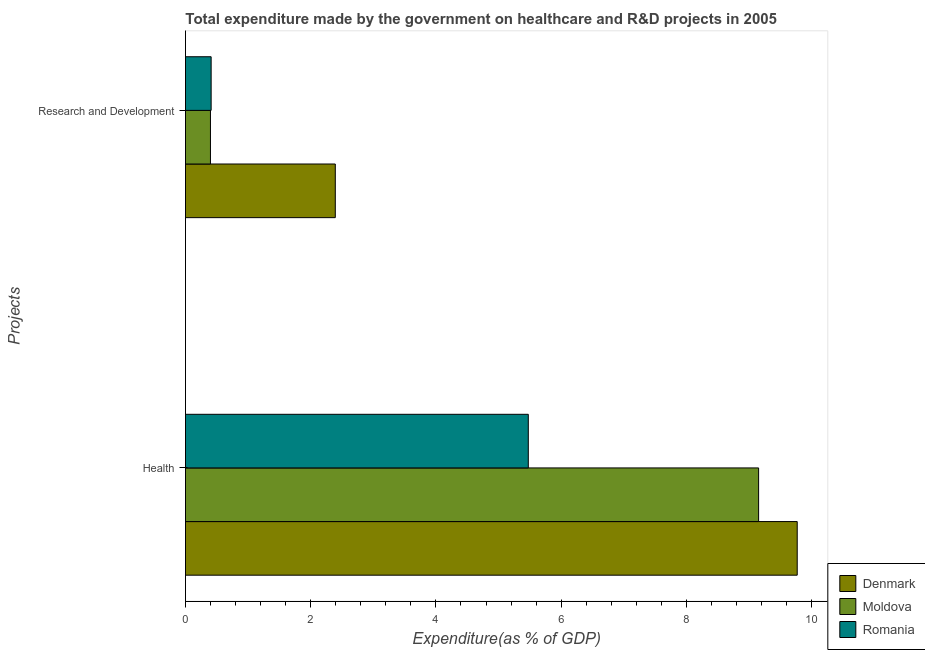How many different coloured bars are there?
Provide a succinct answer. 3. How many bars are there on the 1st tick from the bottom?
Your answer should be compact. 3. What is the label of the 2nd group of bars from the top?
Your answer should be very brief. Health. What is the expenditure in r&d in Romania?
Offer a very short reply. 0.41. Across all countries, what is the maximum expenditure in r&d?
Offer a terse response. 2.39. Across all countries, what is the minimum expenditure in r&d?
Your response must be concise. 0.4. In which country was the expenditure in r&d maximum?
Ensure brevity in your answer.  Denmark. In which country was the expenditure in healthcare minimum?
Ensure brevity in your answer.  Romania. What is the total expenditure in r&d in the graph?
Keep it short and to the point. 3.2. What is the difference between the expenditure in healthcare in Denmark and that in Moldova?
Your response must be concise. 0.62. What is the difference between the expenditure in r&d in Denmark and the expenditure in healthcare in Moldova?
Provide a succinct answer. -6.76. What is the average expenditure in r&d per country?
Provide a succinct answer. 1.07. What is the difference between the expenditure in healthcare and expenditure in r&d in Romania?
Provide a short and direct response. 5.07. What is the ratio of the expenditure in r&d in Denmark to that in Moldova?
Your answer should be very brief. 6. What does the 1st bar from the top in Research and Development represents?
Give a very brief answer. Romania. What does the 2nd bar from the bottom in Health represents?
Offer a terse response. Moldova. How many bars are there?
Offer a terse response. 6. How many countries are there in the graph?
Provide a short and direct response. 3. What is the difference between two consecutive major ticks on the X-axis?
Give a very brief answer. 2. Are the values on the major ticks of X-axis written in scientific E-notation?
Your response must be concise. No. Does the graph contain any zero values?
Keep it short and to the point. No. Where does the legend appear in the graph?
Ensure brevity in your answer.  Bottom right. How many legend labels are there?
Provide a succinct answer. 3. How are the legend labels stacked?
Your answer should be compact. Vertical. What is the title of the graph?
Ensure brevity in your answer.  Total expenditure made by the government on healthcare and R&D projects in 2005. What is the label or title of the X-axis?
Your response must be concise. Expenditure(as % of GDP). What is the label or title of the Y-axis?
Provide a succinct answer. Projects. What is the Expenditure(as % of GDP) of Denmark in Health?
Offer a terse response. 9.77. What is the Expenditure(as % of GDP) of Moldova in Health?
Your answer should be very brief. 9.15. What is the Expenditure(as % of GDP) of Romania in Health?
Your response must be concise. 5.48. What is the Expenditure(as % of GDP) of Denmark in Research and Development?
Make the answer very short. 2.39. What is the Expenditure(as % of GDP) in Moldova in Research and Development?
Make the answer very short. 0.4. What is the Expenditure(as % of GDP) in Romania in Research and Development?
Offer a very short reply. 0.41. Across all Projects, what is the maximum Expenditure(as % of GDP) of Denmark?
Your answer should be very brief. 9.77. Across all Projects, what is the maximum Expenditure(as % of GDP) of Moldova?
Your answer should be very brief. 9.15. Across all Projects, what is the maximum Expenditure(as % of GDP) of Romania?
Your answer should be compact. 5.48. Across all Projects, what is the minimum Expenditure(as % of GDP) in Denmark?
Give a very brief answer. 2.39. Across all Projects, what is the minimum Expenditure(as % of GDP) in Moldova?
Offer a terse response. 0.4. Across all Projects, what is the minimum Expenditure(as % of GDP) in Romania?
Keep it short and to the point. 0.41. What is the total Expenditure(as % of GDP) in Denmark in the graph?
Your answer should be compact. 12.16. What is the total Expenditure(as % of GDP) in Moldova in the graph?
Your answer should be very brief. 9.55. What is the total Expenditure(as % of GDP) of Romania in the graph?
Make the answer very short. 5.88. What is the difference between the Expenditure(as % of GDP) in Denmark in Health and that in Research and Development?
Offer a very short reply. 7.38. What is the difference between the Expenditure(as % of GDP) of Moldova in Health and that in Research and Development?
Offer a very short reply. 8.75. What is the difference between the Expenditure(as % of GDP) in Romania in Health and that in Research and Development?
Provide a short and direct response. 5.07. What is the difference between the Expenditure(as % of GDP) of Denmark in Health and the Expenditure(as % of GDP) of Moldova in Research and Development?
Ensure brevity in your answer.  9.37. What is the difference between the Expenditure(as % of GDP) of Denmark in Health and the Expenditure(as % of GDP) of Romania in Research and Development?
Offer a terse response. 9.36. What is the difference between the Expenditure(as % of GDP) in Moldova in Health and the Expenditure(as % of GDP) in Romania in Research and Development?
Your answer should be very brief. 8.74. What is the average Expenditure(as % of GDP) of Denmark per Projects?
Your answer should be compact. 6.08. What is the average Expenditure(as % of GDP) in Moldova per Projects?
Offer a very short reply. 4.78. What is the average Expenditure(as % of GDP) of Romania per Projects?
Keep it short and to the point. 2.94. What is the difference between the Expenditure(as % of GDP) in Denmark and Expenditure(as % of GDP) in Moldova in Health?
Your answer should be compact. 0.62. What is the difference between the Expenditure(as % of GDP) in Denmark and Expenditure(as % of GDP) in Romania in Health?
Your answer should be compact. 4.29. What is the difference between the Expenditure(as % of GDP) of Moldova and Expenditure(as % of GDP) of Romania in Health?
Give a very brief answer. 3.68. What is the difference between the Expenditure(as % of GDP) of Denmark and Expenditure(as % of GDP) of Moldova in Research and Development?
Your answer should be compact. 1.99. What is the difference between the Expenditure(as % of GDP) in Denmark and Expenditure(as % of GDP) in Romania in Research and Development?
Ensure brevity in your answer.  1.98. What is the difference between the Expenditure(as % of GDP) of Moldova and Expenditure(as % of GDP) of Romania in Research and Development?
Your response must be concise. -0.01. What is the ratio of the Expenditure(as % of GDP) in Denmark in Health to that in Research and Development?
Your answer should be very brief. 4.08. What is the ratio of the Expenditure(as % of GDP) of Moldova in Health to that in Research and Development?
Your answer should be compact. 22.96. What is the ratio of the Expenditure(as % of GDP) in Romania in Health to that in Research and Development?
Ensure brevity in your answer.  13.37. What is the difference between the highest and the second highest Expenditure(as % of GDP) of Denmark?
Offer a terse response. 7.38. What is the difference between the highest and the second highest Expenditure(as % of GDP) of Moldova?
Make the answer very short. 8.75. What is the difference between the highest and the second highest Expenditure(as % of GDP) of Romania?
Your answer should be compact. 5.07. What is the difference between the highest and the lowest Expenditure(as % of GDP) of Denmark?
Offer a terse response. 7.38. What is the difference between the highest and the lowest Expenditure(as % of GDP) of Moldova?
Make the answer very short. 8.75. What is the difference between the highest and the lowest Expenditure(as % of GDP) in Romania?
Offer a terse response. 5.07. 